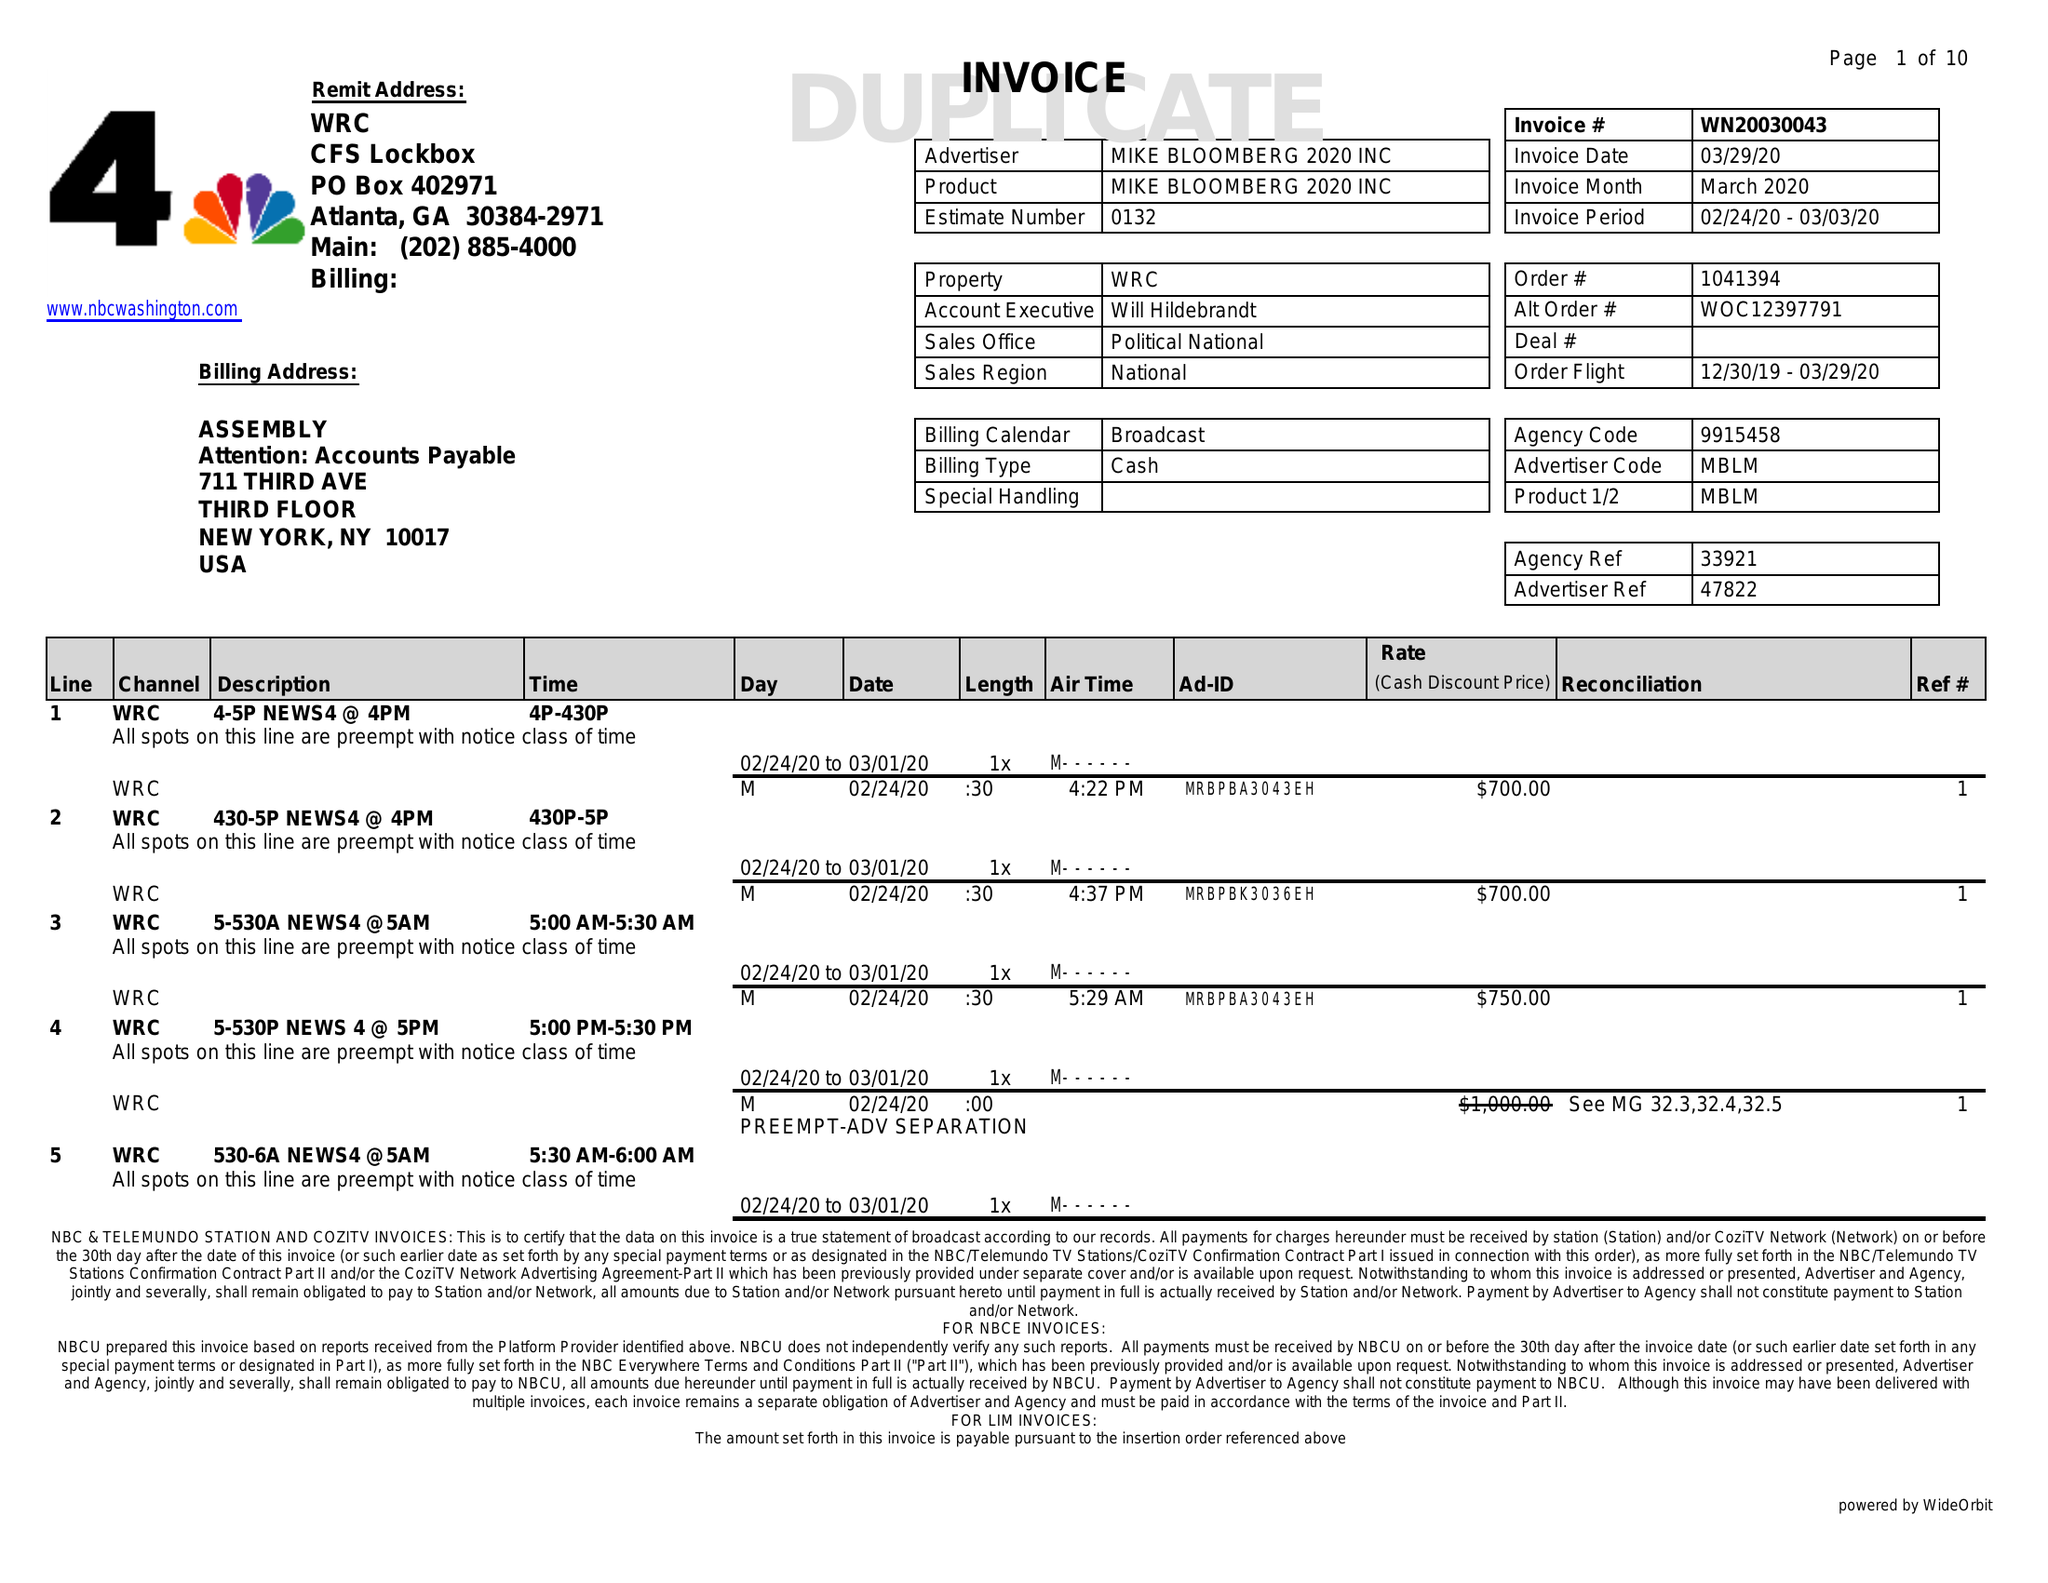What is the value for the advertiser?
Answer the question using a single word or phrase. MIKE BLOOMBERG 2020 INC 